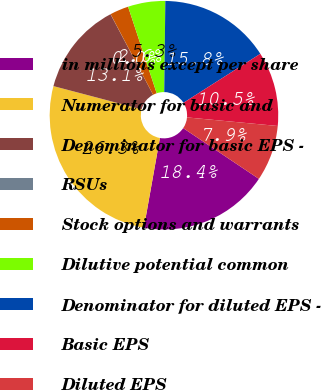Convert chart to OTSL. <chart><loc_0><loc_0><loc_500><loc_500><pie_chart><fcel>in millions except per share<fcel>Numerator for basic and<fcel>Denominator for basic EPS -<fcel>RSUs<fcel>Stock options and warrants<fcel>Dilutive potential common<fcel>Denominator for diluted EPS -<fcel>Basic EPS<fcel>Diluted EPS<nl><fcel>18.41%<fcel>26.29%<fcel>13.15%<fcel>0.02%<fcel>2.65%<fcel>5.27%<fcel>15.78%<fcel>10.53%<fcel>7.9%<nl></chart> 